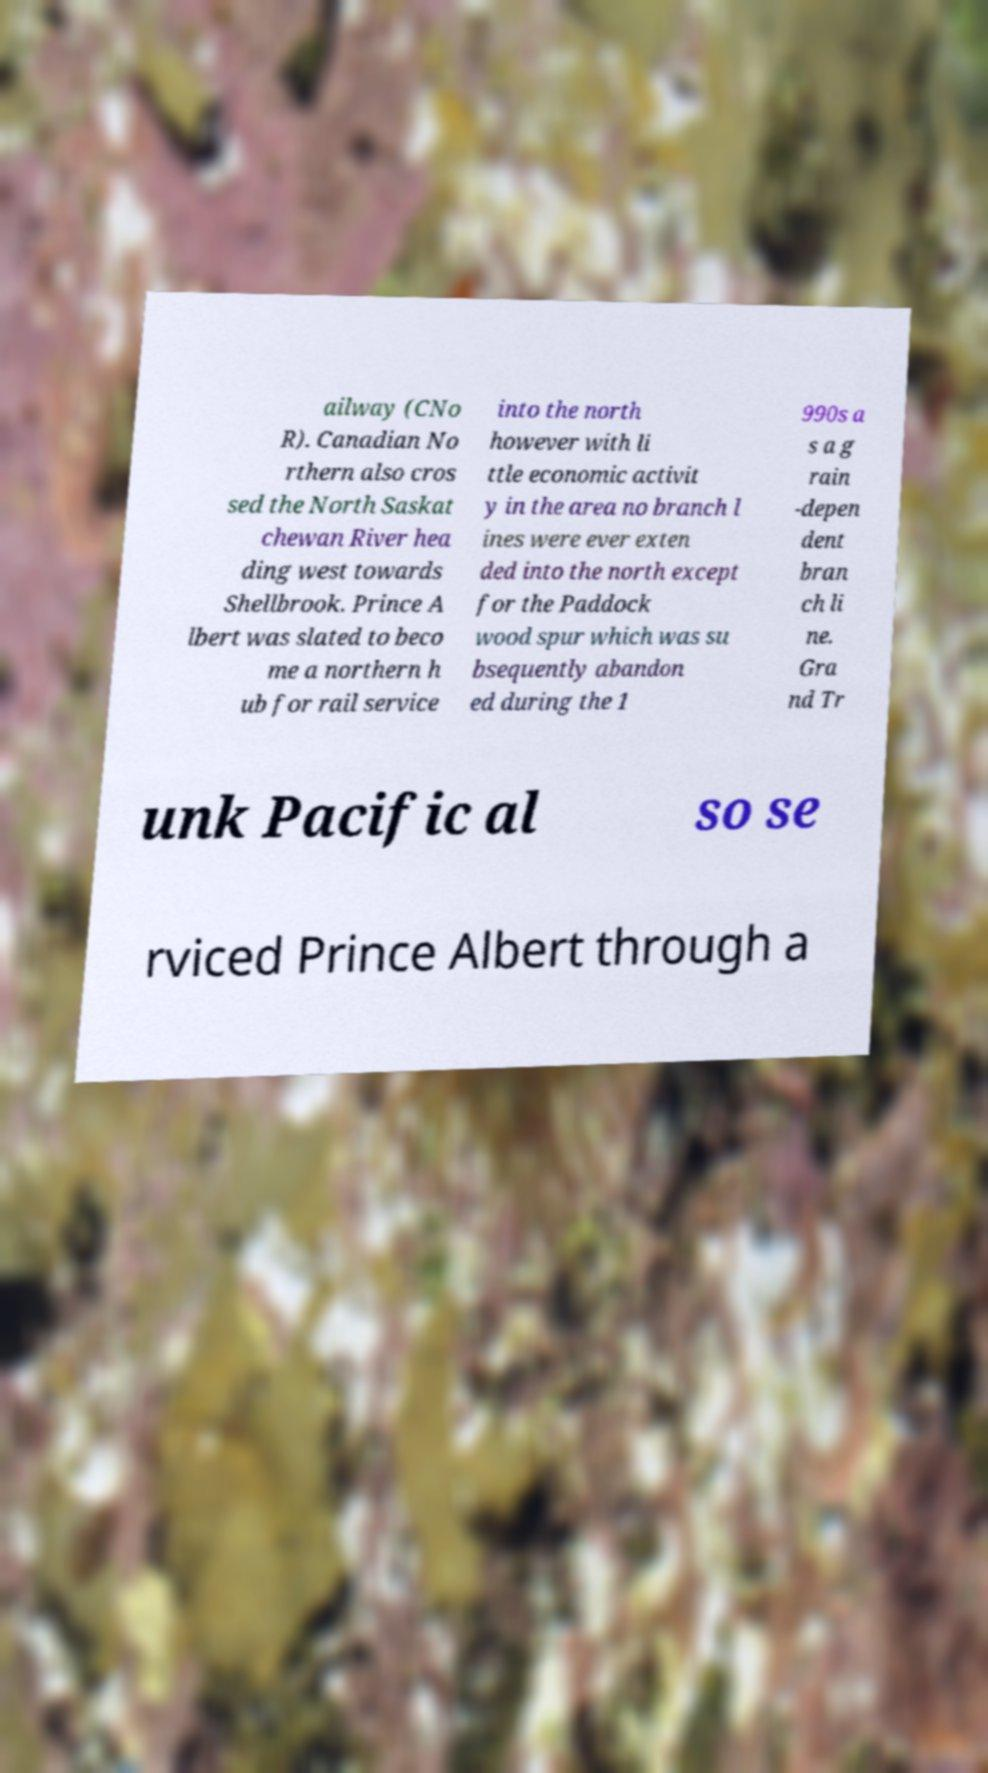Could you extract and type out the text from this image? ailway (CNo R). Canadian No rthern also cros sed the North Saskat chewan River hea ding west towards Shellbrook. Prince A lbert was slated to beco me a northern h ub for rail service into the north however with li ttle economic activit y in the area no branch l ines were ever exten ded into the north except for the Paddock wood spur which was su bsequently abandon ed during the 1 990s a s a g rain -depen dent bran ch li ne. Gra nd Tr unk Pacific al so se rviced Prince Albert through a 